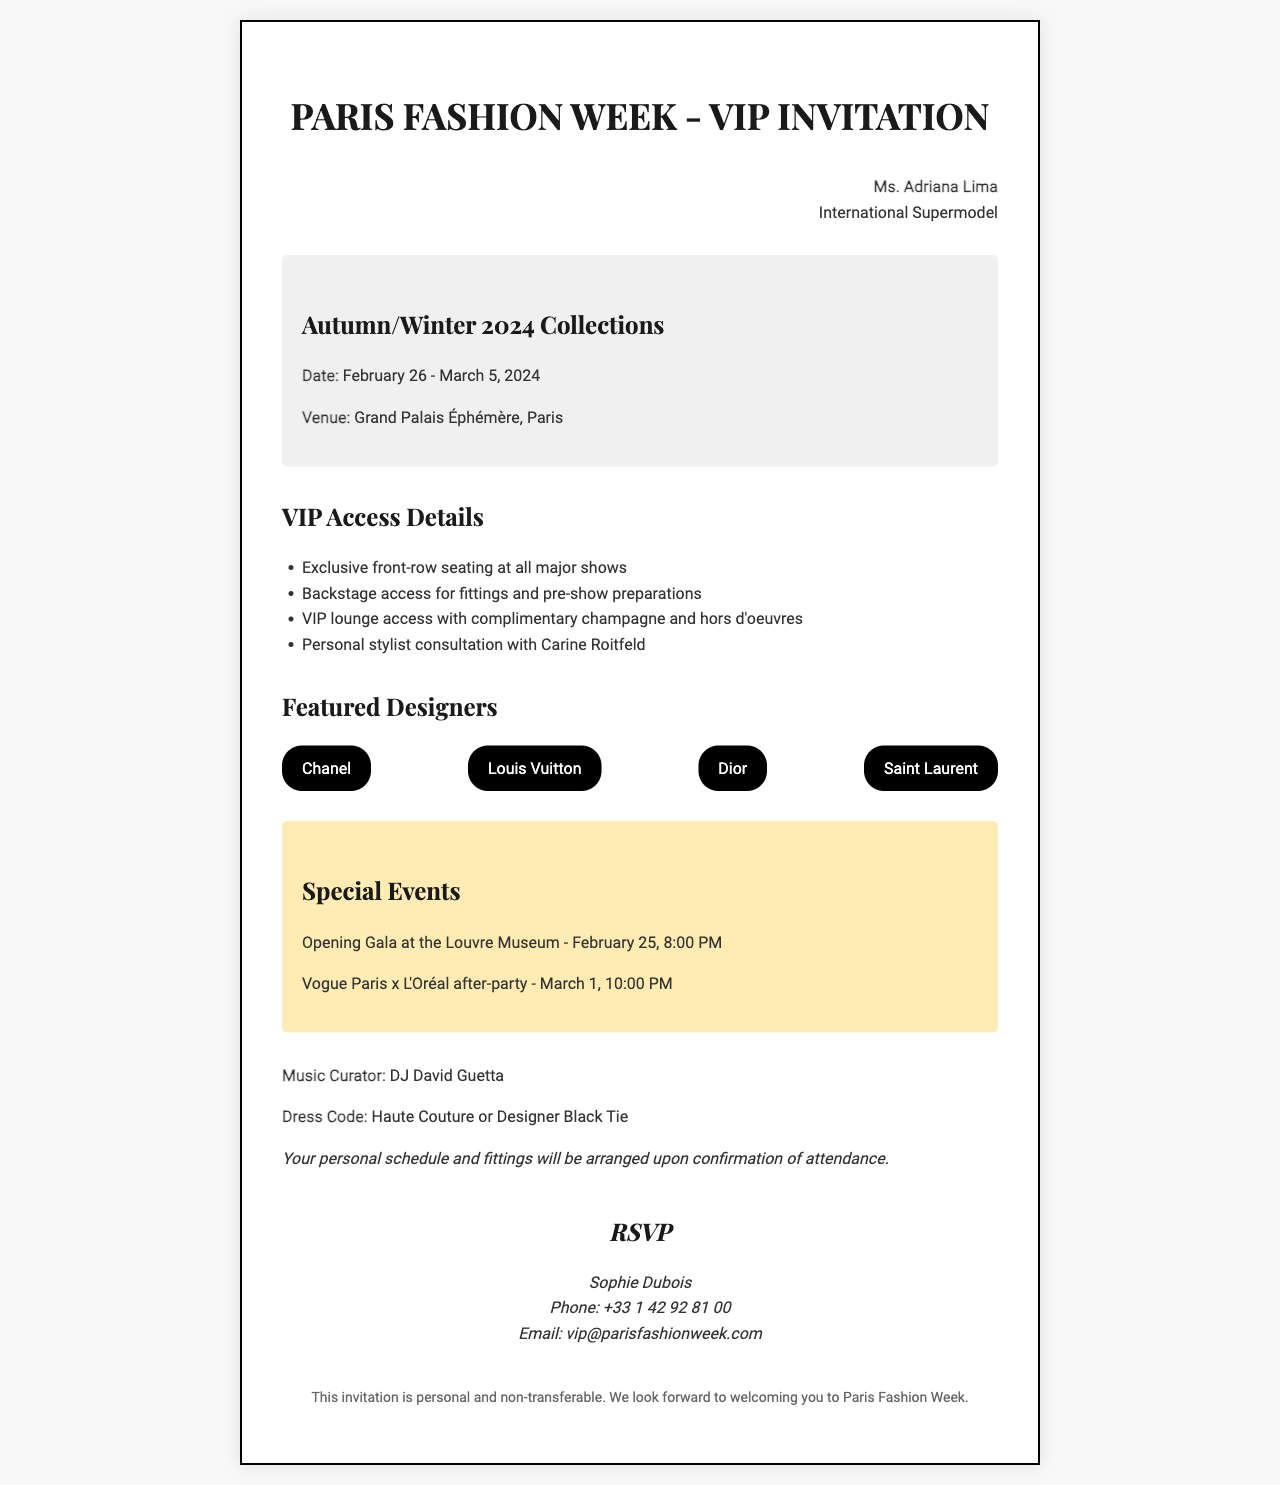What is the date of the event? The date of the event is specified in the document as February 26 - March 5, 2024.
Answer: February 26 - March 5, 2024 Who is the music curator for the event? The document lists DJ David Guetta as the music curator for the event.
Answer: DJ David Guetta What is the venue for the fashion week? The venue is mentioned as Grand Palais Éphémère in Paris.
Answer: Grand Palais Éphémère, Paris What is the dress code for attendees? The dress code is referred to in the document as Haute Couture or Designer Black Tie.
Answer: Haute Couture or Designer Black Tie How many featured designers are listed? The document lists four featured designers during the fashion week event.
Answer: 4 What special event is scheduled for February 25? The document specifies an Opening Gala at the Louvre Museum on February 25.
Answer: Opening Gala at the Louvre Museum What time does the Vogue Paris x L'Oréal after-party start? The document mentions that the after-party is set to start at 10:00 PM on March 1.
Answer: 10:00 PM What is the contact email for RSVPs? The RSVP details include the email address vip@parisfashionweek.com for confirmations.
Answer: vip@parisfashionweek.com What type of invitation is this classified as? The document states that this invitation is personal and non-transferable.
Answer: personal and non-transferable 